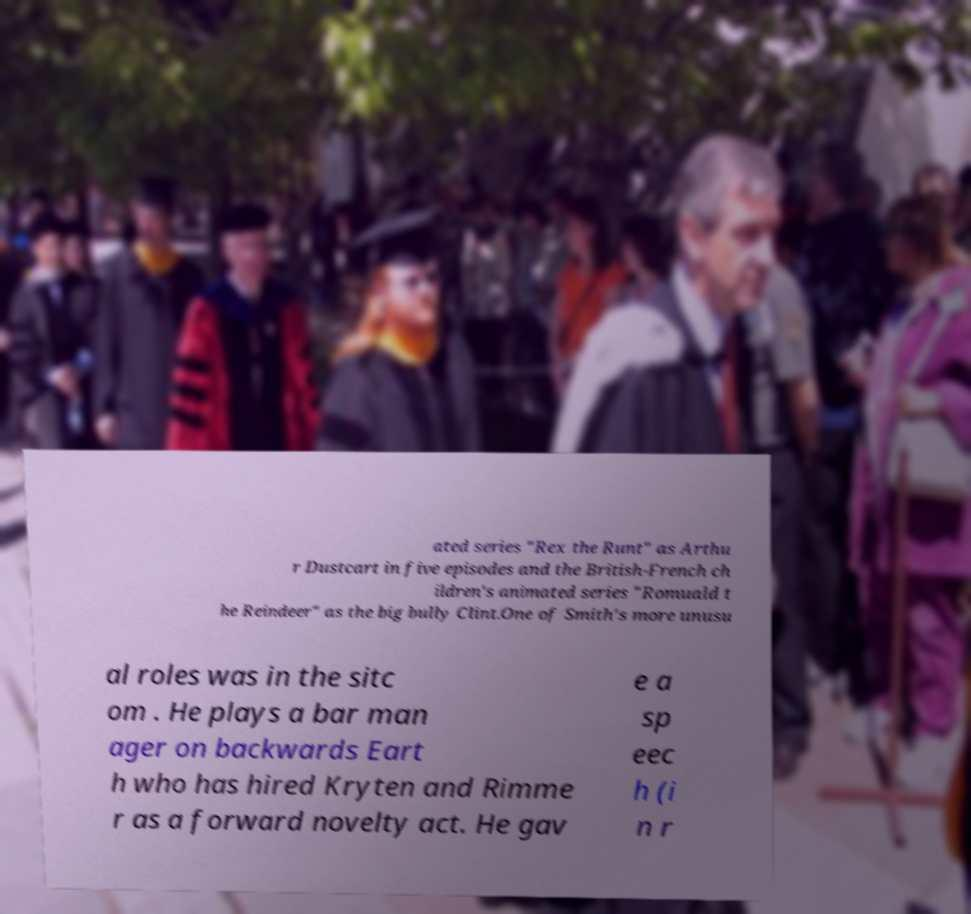For documentation purposes, I need the text within this image transcribed. Could you provide that? ated series "Rex the Runt" as Arthu r Dustcart in five episodes and the British-French ch ildren's animated series "Romuald t he Reindeer" as the big bully Clint.One of Smith's more unusu al roles was in the sitc om . He plays a bar man ager on backwards Eart h who has hired Kryten and Rimme r as a forward novelty act. He gav e a sp eec h (i n r 